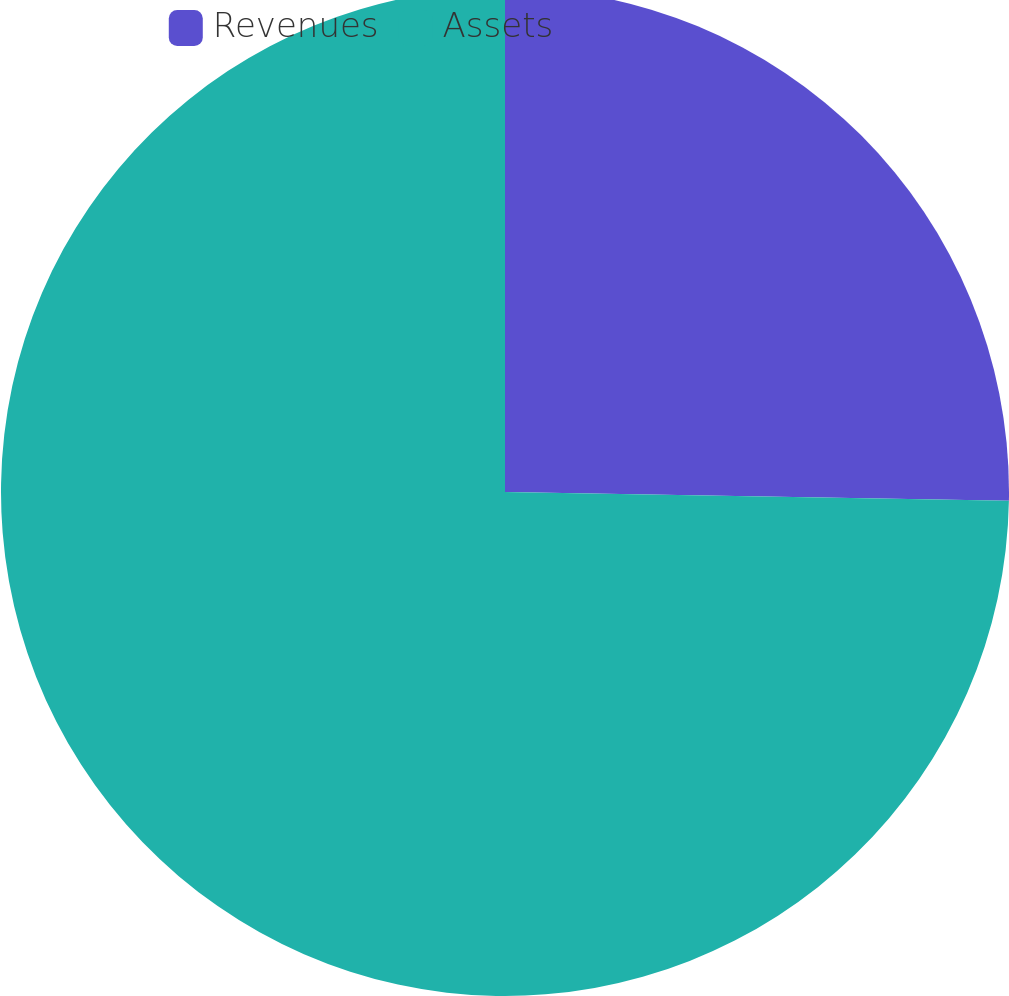Convert chart to OTSL. <chart><loc_0><loc_0><loc_500><loc_500><pie_chart><fcel>Revenues<fcel>Assets<nl><fcel>25.28%<fcel>74.72%<nl></chart> 